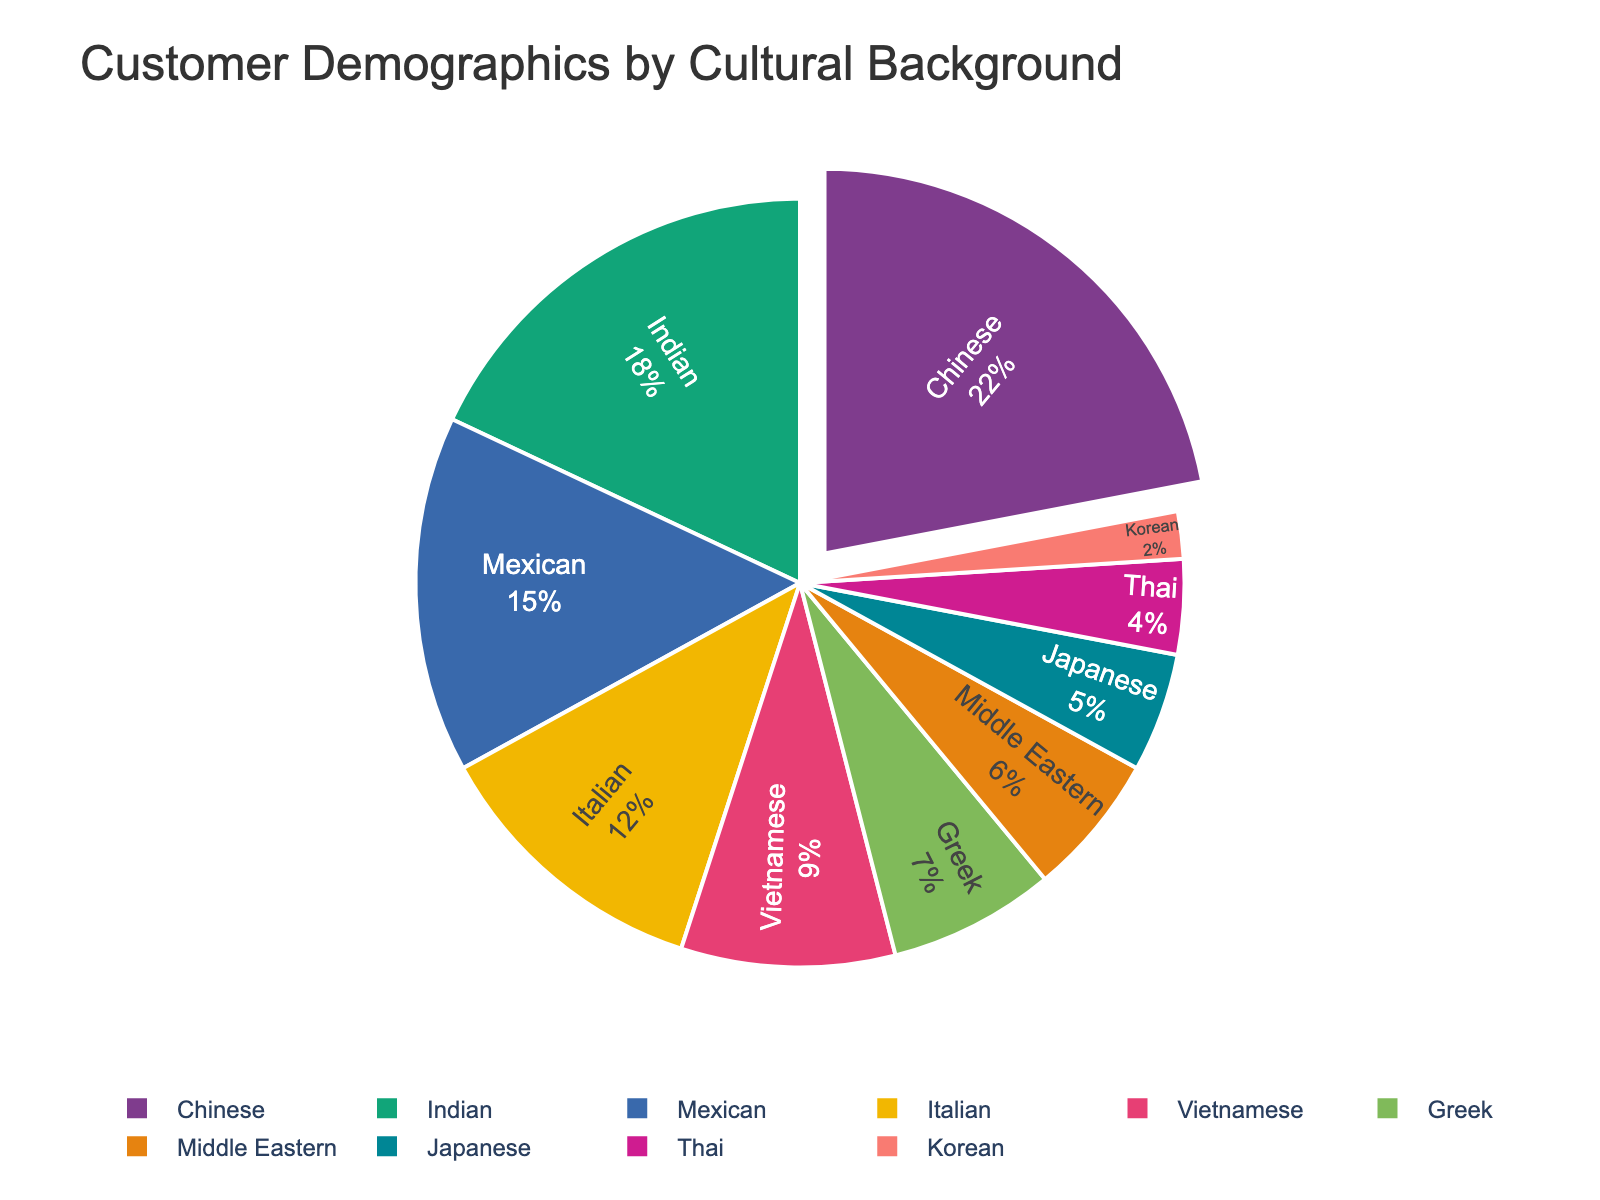What percentage of your customers come from the Chinese demographic? According to the figure, the Chinese demographic makes up 22% of the customer base.
Answer: 22% Which cultural background has the lowest representation in your store's customer demographics? Observing the pie chart, the Korean demographic has the lowest percentage of 2%.
Answer: Korean Which two cultural backgrounds combined make up the largest percentage of your customer base? The Chinese and Indian demographics make up 22% and 18% respectively. Their combined percentage is 22% + 18% = 40%.
Answer: Chinese and Indian How does the percentage of Vietnamese customers compare to the percentage of Greek customers? The Vietnamese customer percentage is 9% whereas the Greek customer percentage is 7%. Therefore, Vietnamese customers represent a higher percentage.
Answer: Vietnamese customers represent a higher percentage What is the total percentage for customers from Asian backgrounds (Chinese, Indian, Vietnamese, Japanese, Korean)? Sum the percentages: Chinese (22%) + Indian (18%) + Vietnamese (9%) + Japanese (5%) + Korean (2%) = 56%.
Answer: 56% Is there a cultural background that constitutes exactly 12% of the customer base? By examining the pie chart, the Italian demographic constitutes exactly 12% of the customer base.
Answer: Italian Between Thai and Middle Eastern customers, which group represents a larger segment of your customer base and by how much? Thai customers represent 4%, and Middle Eastern customers represent 6%. The difference is 6% - 4% = 2%.
Answer: Middle Eastern by 2% How many cultural backgrounds account for more than 10% of your customer demographics? The Chinese (22%), Indian (18%), Mexican (15%), and Italian (12%) each account for more than 10%. There are 4 such backgrounds.
Answer: 4 What is the combined percentage for the smallest three demographic groups? Adding the smallest percentages: Korean (2%) + Thai (4%) + Japanese (5%) = 11%.
Answer: 11% Does any cultural background make up more than one-fifth of the customer base? The Chinese demographic at 22% makes up more than one-fifth (20%) of the customer base.
Answer: Yes, Chinese 